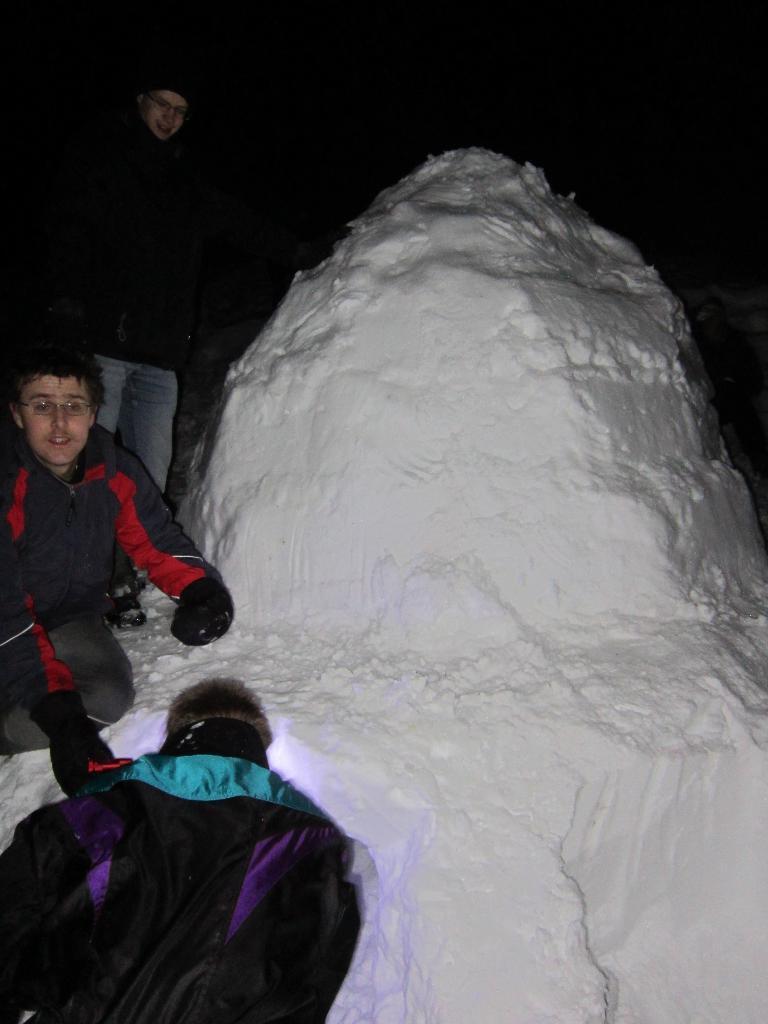Could you give a brief overview of what you see in this image? On the right of this picture we can see there is a lot of snow. On the left we can see the two people seems to be sitting and we can see a person standing on the ground. The background of the image is very dark. In the right corner we can see a person like thing. 